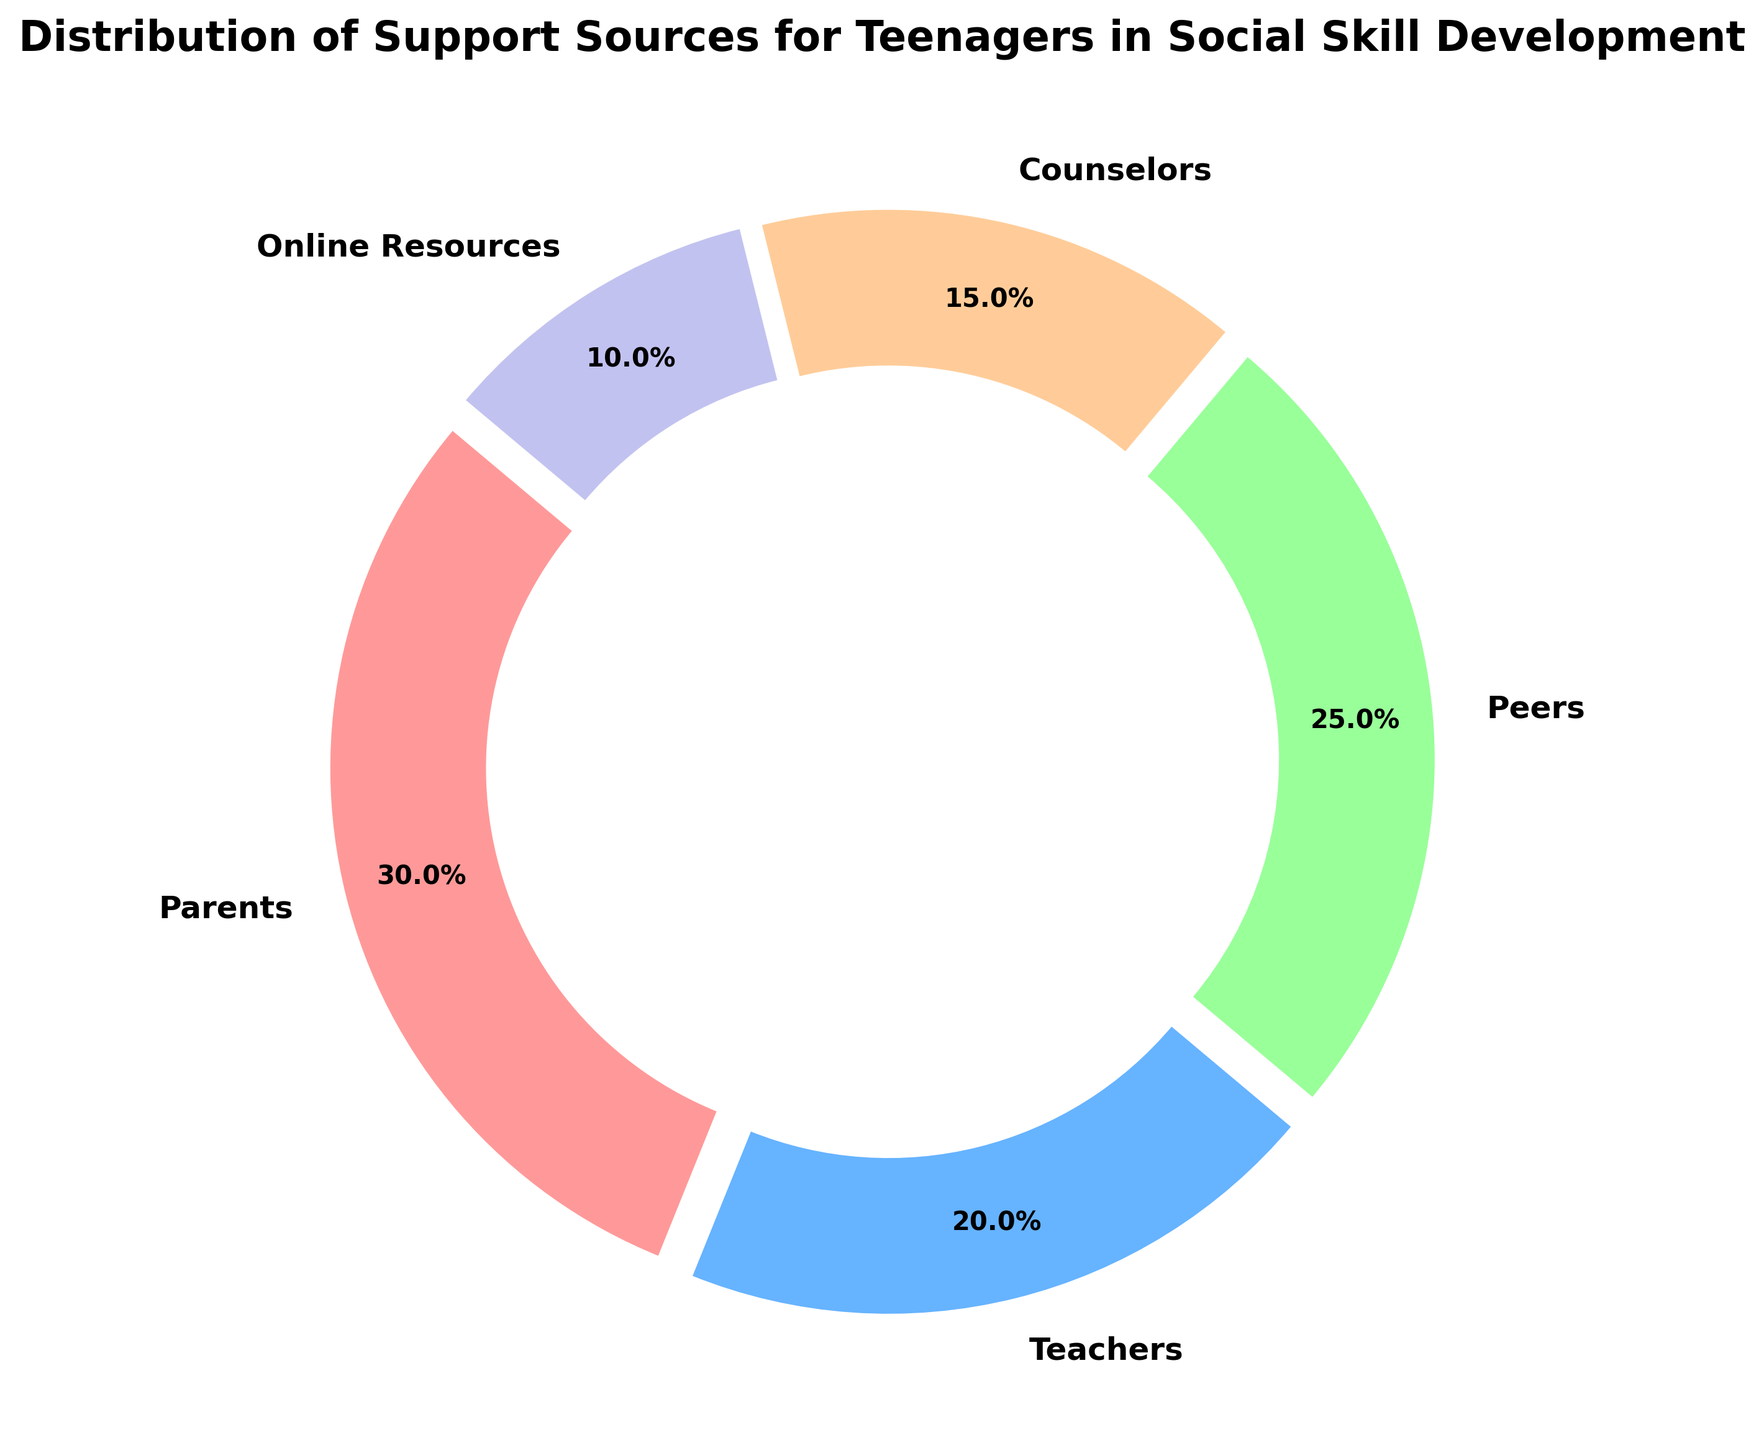What percentage of the support sources are non-parental? Calculate the sum of the percentages of all support sources except 'Parents': 20% (Teachers) + 25% (Peers) + 15% (Counselors) + 10% (Online Resources).
Answer: 70% Which support source offers the least percentage? Identify the segment with the smallest percentage. The smallest percentage in the chart is represented by 'Online Resources' at 10%.
Answer: Online Resources Compare the combined percentage of counselors and online resources with that of peers. Which one is higher? Sum the percentages of counselors and online resources: 15% (Counselors) + 10% (Online Resources) = 25%. The percentage for peers is 25%. So both are equal.
Answer: Both are equal What is the difference in percentage between the highest and lowest support sources? Identify the highest (Parents: 30%) and lowest (Online Resources: 10%) percentages. Then calculate the difference: 30% - 10%.
Answer: 20% What's the combined support percentage from teachers and peers? Sum the percentages of teachers and peers: 20% (Teachers) + 25% (Peers).
Answer: 45% Which support sources are represented in adjacent segments of the same color group? The colors define individual segments. Ensure this is accurate via visual inspection: adjacent segments (often distinguished by explode placement). Confirm visually that adjacent segments don't share the same color. Note: Verification shows no segments share the same adjacent color group.
Answer: No adjacent segments If the support from parents decreased by 10% and that from teachers increased by the same amount, what would the new percentages be? Would there be any new highest or lowest support sources? Original percentages: Parents 30%, Teachers 20%. New percentages: Parents 30% - 10% = 20%, Teachers 20% + 10% = 30%. Compare new values. New highest: Teachers 30%. New lowest remains Online Resources (10%).
Answer: New High: Teachers; New Low: Online Resources How do the visual styles (colors and exploded segments) help in interpreting the chart? Colors help differentiate each category, making it easier to see distinctions. The exploded segments emphasize each category's importance.
Answer: Distinction and emphasis What is the average percentage of all five support sources? Calculate the average: (30 + 20 + 25 + 15 + 10) / 5 = 100 / 5.
Answer: 20% Which pair of support sources has a combined percentage exceeding 50%? Check pair combinations: e.g., if Parents (30%) + Peers (25%) = 55%, exceeds 50%. Other combinations like Parents (30%) + Teachers (20%) = 50% do not exceed. Parents and Peers exceed 50%.
Answer: Parents and Peers 